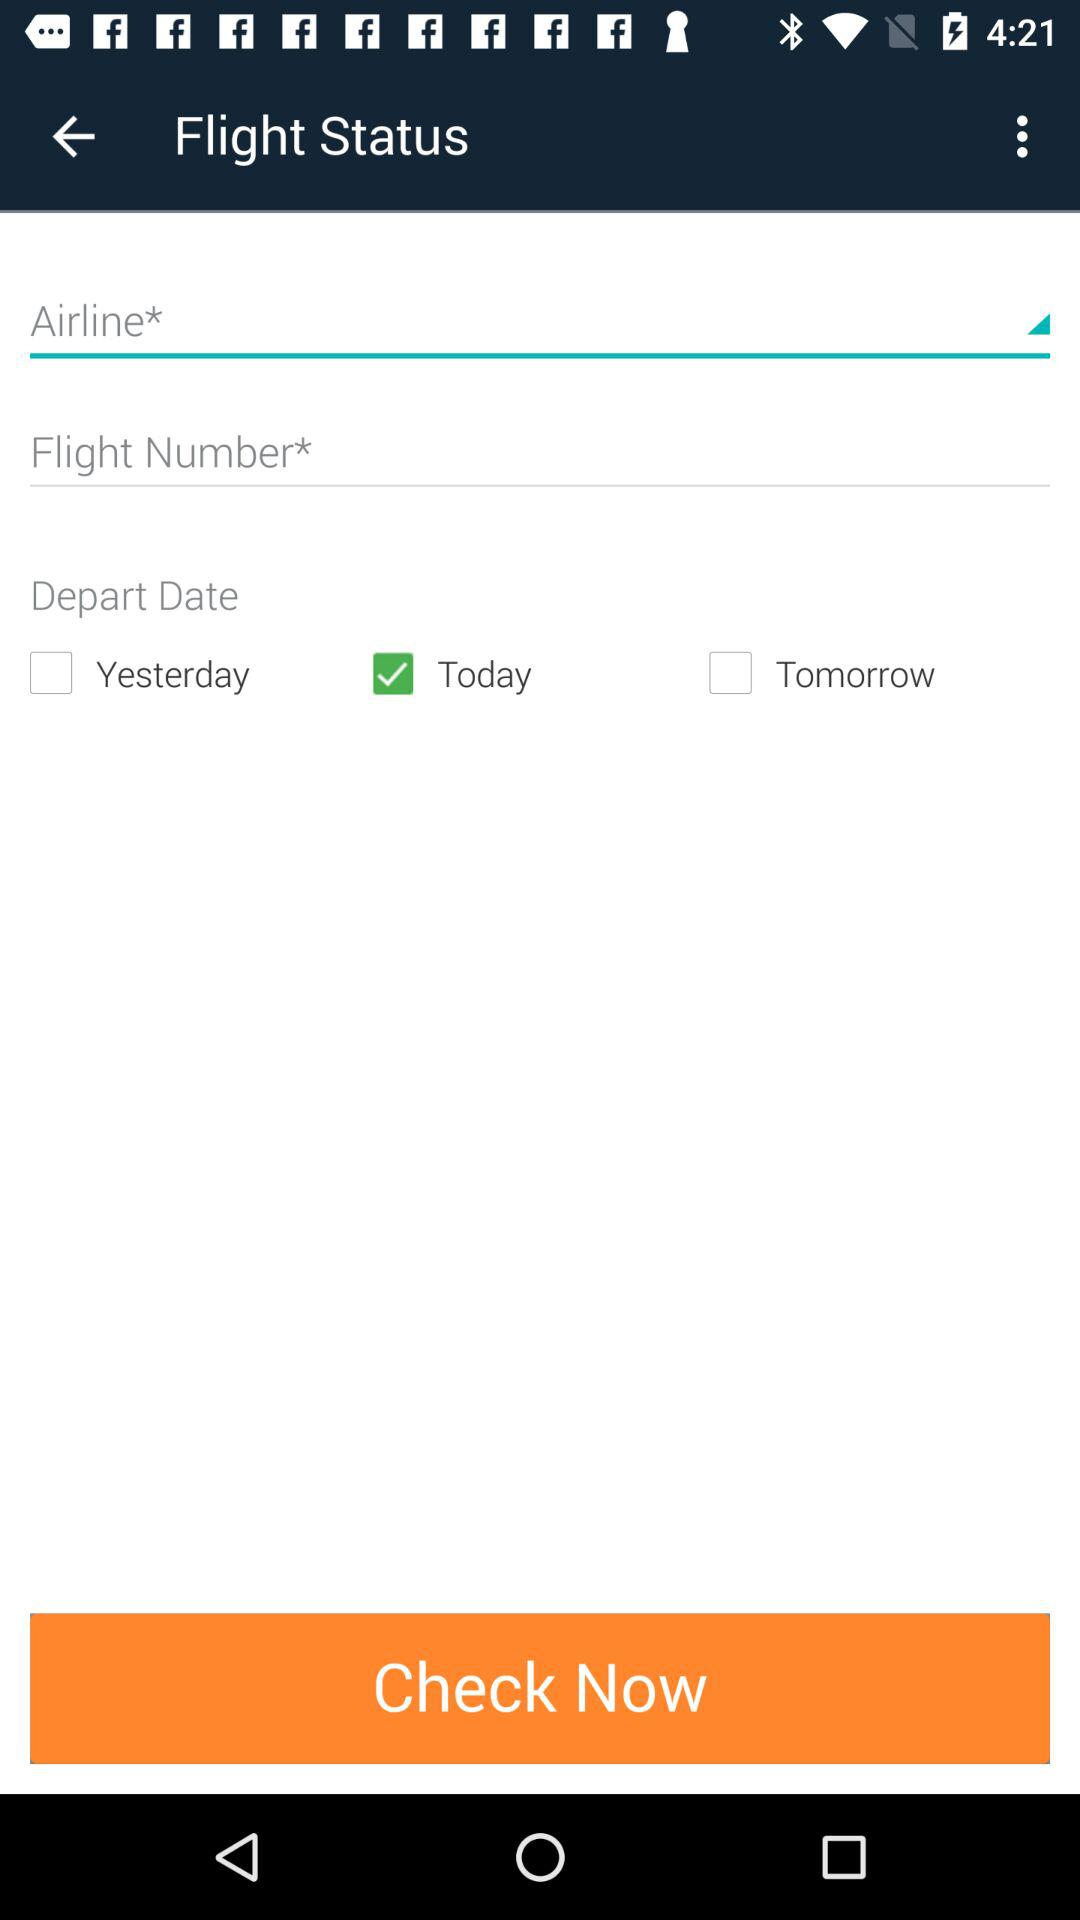Which option is marked as checked for "Depart Date"? The option that is marked as checked for "Depart Date" is "Today". 